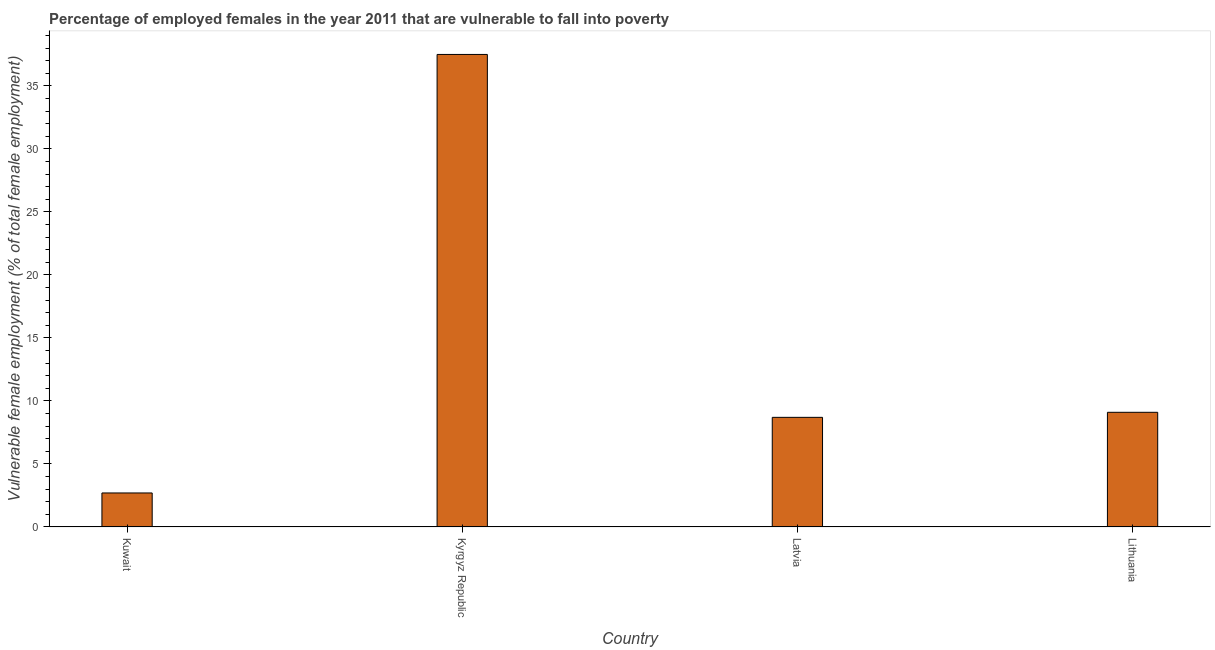What is the title of the graph?
Provide a succinct answer. Percentage of employed females in the year 2011 that are vulnerable to fall into poverty. What is the label or title of the X-axis?
Provide a succinct answer. Country. What is the label or title of the Y-axis?
Ensure brevity in your answer.  Vulnerable female employment (% of total female employment). What is the percentage of employed females who are vulnerable to fall into poverty in Latvia?
Provide a short and direct response. 8.7. Across all countries, what is the maximum percentage of employed females who are vulnerable to fall into poverty?
Your answer should be compact. 37.5. Across all countries, what is the minimum percentage of employed females who are vulnerable to fall into poverty?
Make the answer very short. 2.7. In which country was the percentage of employed females who are vulnerable to fall into poverty maximum?
Offer a very short reply. Kyrgyz Republic. In which country was the percentage of employed females who are vulnerable to fall into poverty minimum?
Offer a terse response. Kuwait. What is the sum of the percentage of employed females who are vulnerable to fall into poverty?
Your answer should be very brief. 58. What is the difference between the percentage of employed females who are vulnerable to fall into poverty in Kyrgyz Republic and Lithuania?
Your response must be concise. 28.4. What is the median percentage of employed females who are vulnerable to fall into poverty?
Keep it short and to the point. 8.9. What is the ratio of the percentage of employed females who are vulnerable to fall into poverty in Kuwait to that in Kyrgyz Republic?
Your answer should be very brief. 0.07. Is the difference between the percentage of employed females who are vulnerable to fall into poverty in Kuwait and Latvia greater than the difference between any two countries?
Your answer should be compact. No. What is the difference between the highest and the second highest percentage of employed females who are vulnerable to fall into poverty?
Give a very brief answer. 28.4. Is the sum of the percentage of employed females who are vulnerable to fall into poverty in Kuwait and Kyrgyz Republic greater than the maximum percentage of employed females who are vulnerable to fall into poverty across all countries?
Offer a very short reply. Yes. What is the difference between the highest and the lowest percentage of employed females who are vulnerable to fall into poverty?
Give a very brief answer. 34.8. How many bars are there?
Keep it short and to the point. 4. Are all the bars in the graph horizontal?
Provide a succinct answer. No. What is the difference between two consecutive major ticks on the Y-axis?
Your answer should be compact. 5. What is the Vulnerable female employment (% of total female employment) in Kuwait?
Provide a short and direct response. 2.7. What is the Vulnerable female employment (% of total female employment) in Kyrgyz Republic?
Your answer should be compact. 37.5. What is the Vulnerable female employment (% of total female employment) of Latvia?
Make the answer very short. 8.7. What is the Vulnerable female employment (% of total female employment) of Lithuania?
Ensure brevity in your answer.  9.1. What is the difference between the Vulnerable female employment (% of total female employment) in Kuwait and Kyrgyz Republic?
Give a very brief answer. -34.8. What is the difference between the Vulnerable female employment (% of total female employment) in Kuwait and Latvia?
Give a very brief answer. -6. What is the difference between the Vulnerable female employment (% of total female employment) in Kyrgyz Republic and Latvia?
Offer a terse response. 28.8. What is the difference between the Vulnerable female employment (% of total female employment) in Kyrgyz Republic and Lithuania?
Your answer should be compact. 28.4. What is the difference between the Vulnerable female employment (% of total female employment) in Latvia and Lithuania?
Your answer should be compact. -0.4. What is the ratio of the Vulnerable female employment (% of total female employment) in Kuwait to that in Kyrgyz Republic?
Offer a terse response. 0.07. What is the ratio of the Vulnerable female employment (% of total female employment) in Kuwait to that in Latvia?
Give a very brief answer. 0.31. What is the ratio of the Vulnerable female employment (% of total female employment) in Kuwait to that in Lithuania?
Provide a succinct answer. 0.3. What is the ratio of the Vulnerable female employment (% of total female employment) in Kyrgyz Republic to that in Latvia?
Make the answer very short. 4.31. What is the ratio of the Vulnerable female employment (% of total female employment) in Kyrgyz Republic to that in Lithuania?
Ensure brevity in your answer.  4.12. What is the ratio of the Vulnerable female employment (% of total female employment) in Latvia to that in Lithuania?
Ensure brevity in your answer.  0.96. 